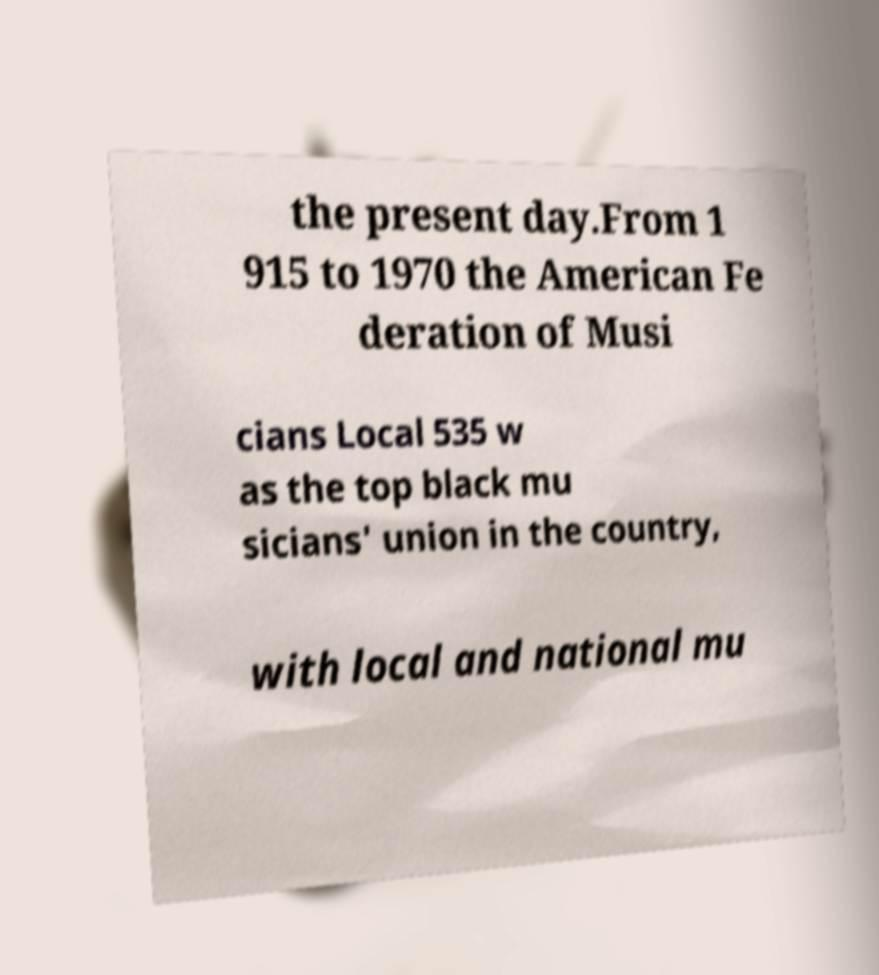There's text embedded in this image that I need extracted. Can you transcribe it verbatim? the present day.From 1 915 to 1970 the American Fe deration of Musi cians Local 535 w as the top black mu sicians' union in the country, with local and national mu 